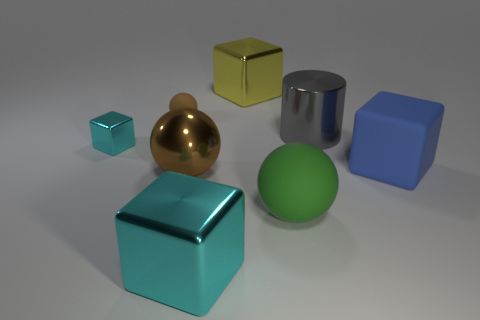What could be the purpose of these objects together in one setting? These objects could serve several purposes. They might be part of a 3D modeling software test environment used to assess rendering techniques or lighting effects. They can help illustrate how different textures and colors interact under varied light conditions. Alternatively, this could be an educational setup demonstrating shapes and materials in a visual manner, or even a simple aesthetic composition created by a 3D artist to showcase their skills in modeling, texturing, and lighting within a virtual space. 